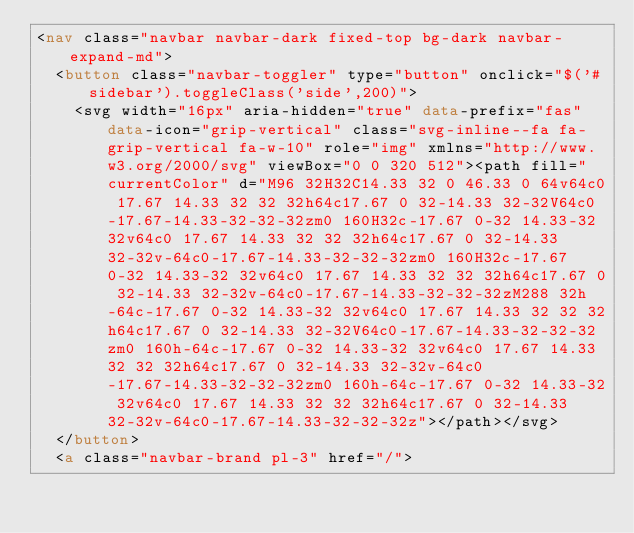Convert code to text. <code><loc_0><loc_0><loc_500><loc_500><_HTML_><nav class="navbar navbar-dark fixed-top bg-dark navbar-expand-md">
  <button class="navbar-toggler" type="button" onclick="$('#sidebar').toggleClass('side',200)">
    <svg width="16px" aria-hidden="true" data-prefix="fas" data-icon="grip-vertical" class="svg-inline--fa fa-grip-vertical fa-w-10" role="img" xmlns="http://www.w3.org/2000/svg" viewBox="0 0 320 512"><path fill="currentColor" d="M96 32H32C14.33 32 0 46.33 0 64v64c0 17.67 14.33 32 32 32h64c17.67 0 32-14.33 32-32V64c0-17.67-14.33-32-32-32zm0 160H32c-17.67 0-32 14.33-32 32v64c0 17.67 14.33 32 32 32h64c17.67 0 32-14.33 32-32v-64c0-17.67-14.33-32-32-32zm0 160H32c-17.67 0-32 14.33-32 32v64c0 17.67 14.33 32 32 32h64c17.67 0 32-14.33 32-32v-64c0-17.67-14.33-32-32-32zM288 32h-64c-17.67 0-32 14.33-32 32v64c0 17.67 14.33 32 32 32h64c17.67 0 32-14.33 32-32V64c0-17.67-14.33-32-32-32zm0 160h-64c-17.67 0-32 14.33-32 32v64c0 17.67 14.33 32 32 32h64c17.67 0 32-14.33 32-32v-64c0-17.67-14.33-32-32-32zm0 160h-64c-17.67 0-32 14.33-32 32v64c0 17.67 14.33 32 32 32h64c17.67 0 32-14.33 32-32v-64c0-17.67-14.33-32-32-32z"></path></svg>
  </button>
  <a class="navbar-brand pl-3" href="/"></code> 